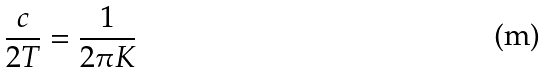Convert formula to latex. <formula><loc_0><loc_0><loc_500><loc_500>\frac { c } { 2 T } = \frac { 1 } { 2 \pi K }</formula> 